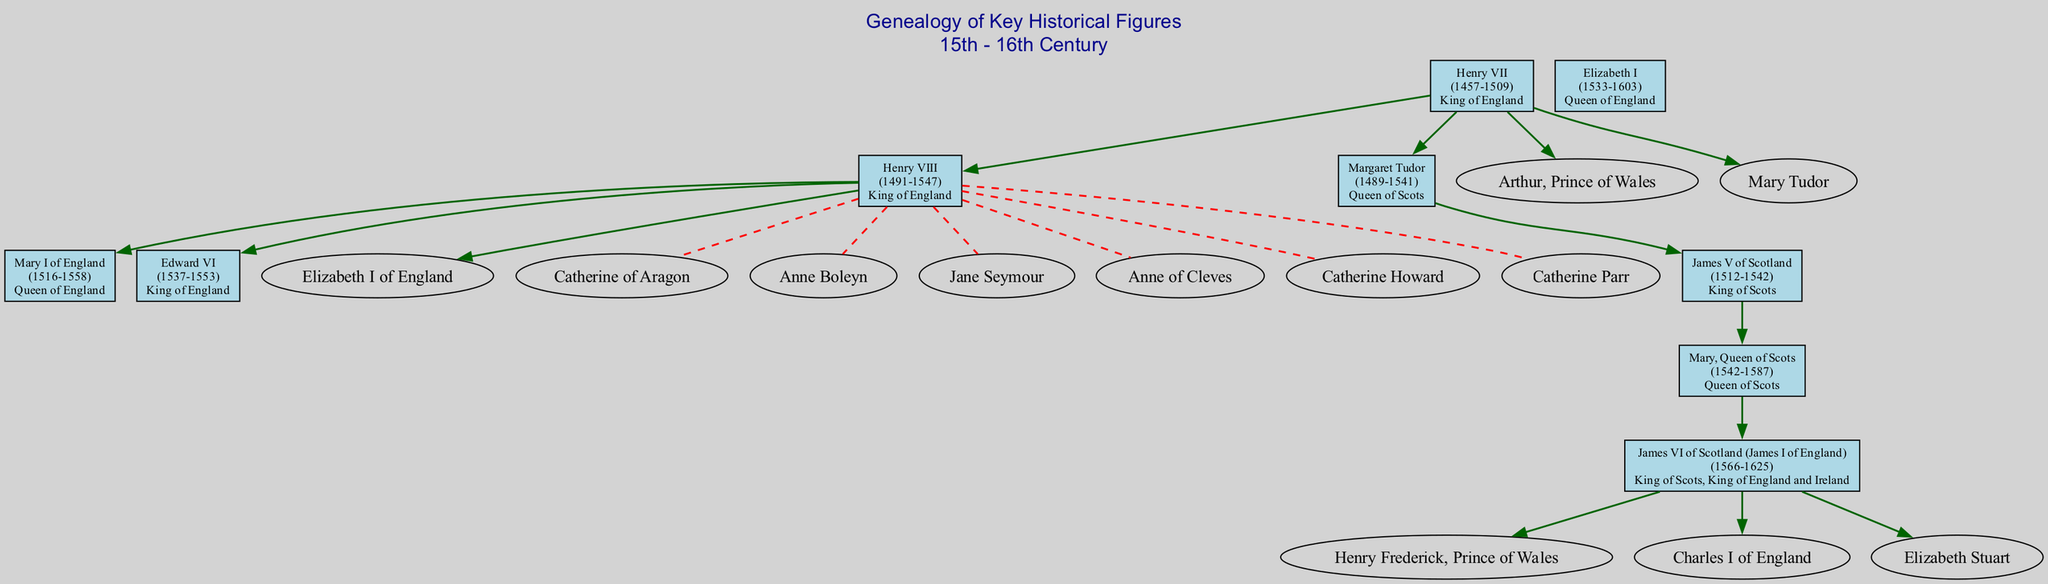What is the birth year of Henry VIII? The diagram shows that Henry VIII was born in the year 1491, which can be found in the node labeled with his name.
Answer: 1491 Who are the parents of Elizabeth I? Referring to the diagram, Elizabeth I has two parents listed: Henry VIII and Anne Boleyn, which are noted in her node.
Answer: Henry VIII, Anne Boleyn How many children did Henry VIII have? By examining the node for Henry VIII, I can count three children listed: Mary I of England, Elizabeth I of England, and Edward VI.
Answer: 3 Which historical figure is connected to both James V of Scotland and James IV of Scotland? The node for James V of Scotland indicates that he is the child of James IV of Scotland and Margaret Tudor, thus both figures are connected to him.
Answer: James IV, Margaret Tudor How many spouses did Henry VIII have? Henry VIII's node lists a total of six spouses: Catherine of Aragon, Anne Boleyn, Jane Seymour, Anne of Cleves, Catherine Howard, and Catherine Parr, which can be counted directly from the node's content.
Answer: 6 Which historical figure’s children include Mary, Queen of Scots? The node for James V of Scotland shows that he has one child, Mary, Queen of Scots, clearly indicating this relationship in the family tree.
Answer: James V of Scotland What role did Margaret Tudor play? According to her node, Margaret Tudor is identified as Queen of Scots, which is specified directly in her description.
Answer: Queen of Scots Who is the direct descendant of Mary, Queen of Scots? Looking at the information associated with Mary, Queen of Scots in the diagram, it states that her child is James VI of Scotland (James I of England), establishing this lineage.
Answer: James VI of Scotland (James I of England) What is the relationship between Elizabeth I and Henry VII? The diagram reveals that Elizabeth I is the grandchild of Henry VII through her father, Henry VIII, indicating a direct descendant relationship.
Answer: Grandchild 